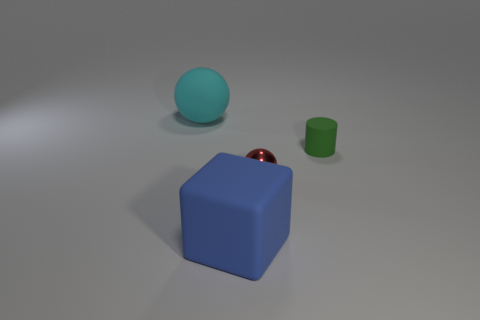What shape is the large object in front of the sphere left of the blue thing?
Your answer should be very brief. Cube. What shape is the blue thing?
Offer a terse response. Cube. What is the material of the sphere that is left of the ball in front of the big rubber thing that is behind the green cylinder?
Provide a short and direct response. Rubber. How many other things are made of the same material as the cyan ball?
Offer a very short reply. 2. How many cyan balls are to the left of the matte thing that is behind the small matte cylinder?
Offer a terse response. 0. How many cubes are large matte objects or big gray things?
Provide a short and direct response. 1. What is the color of the thing that is left of the tiny red sphere and behind the small metal ball?
Keep it short and to the point. Cyan. Are there any other things that are the same color as the big matte sphere?
Offer a very short reply. No. What color is the sphere that is in front of the big rubber object behind the red metallic sphere?
Give a very brief answer. Red. Is the cyan matte ball the same size as the matte cylinder?
Keep it short and to the point. No. 